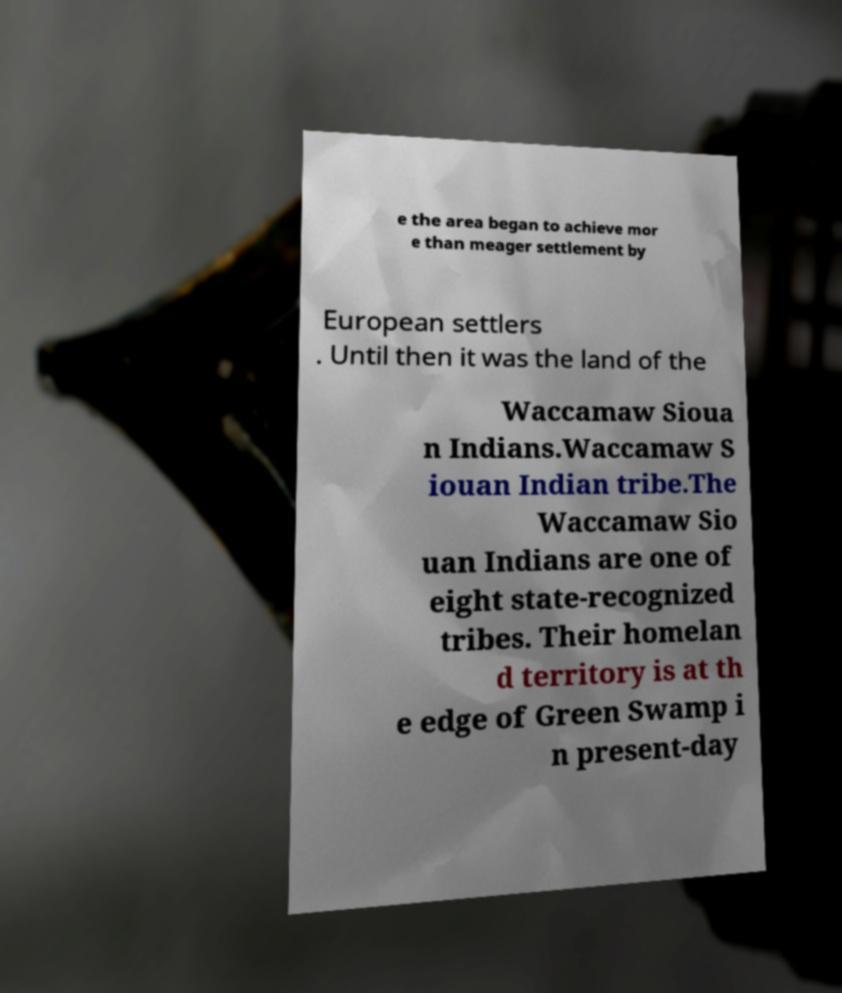Could you assist in decoding the text presented in this image and type it out clearly? e the area began to achieve mor e than meager settlement by European settlers . Until then it was the land of the Waccamaw Sioua n Indians.Waccamaw S iouan Indian tribe.The Waccamaw Sio uan Indians are one of eight state-recognized tribes. Their homelan d territory is at th e edge of Green Swamp i n present-day 